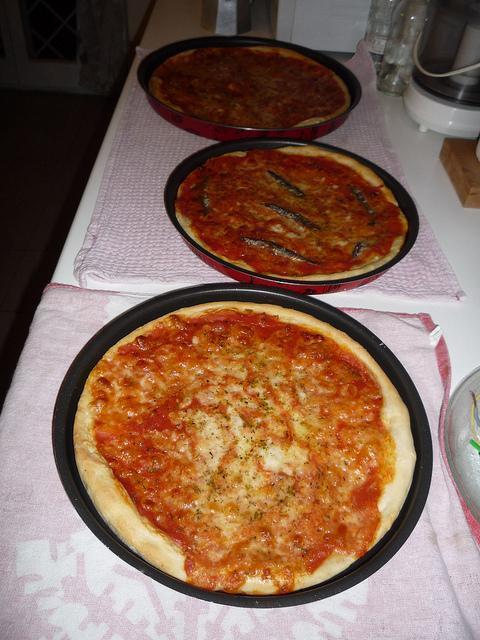What is the largest pizza on top of?
Indicate the correct choice and explain in the format: 'Answer: answer
Rationale: rationale.'
Options: Wooden board, paper plate, aluminum tray, tray. Answer: tray.
Rationale: These types of food are piping hot and need to be served with something that will hold them in place. 